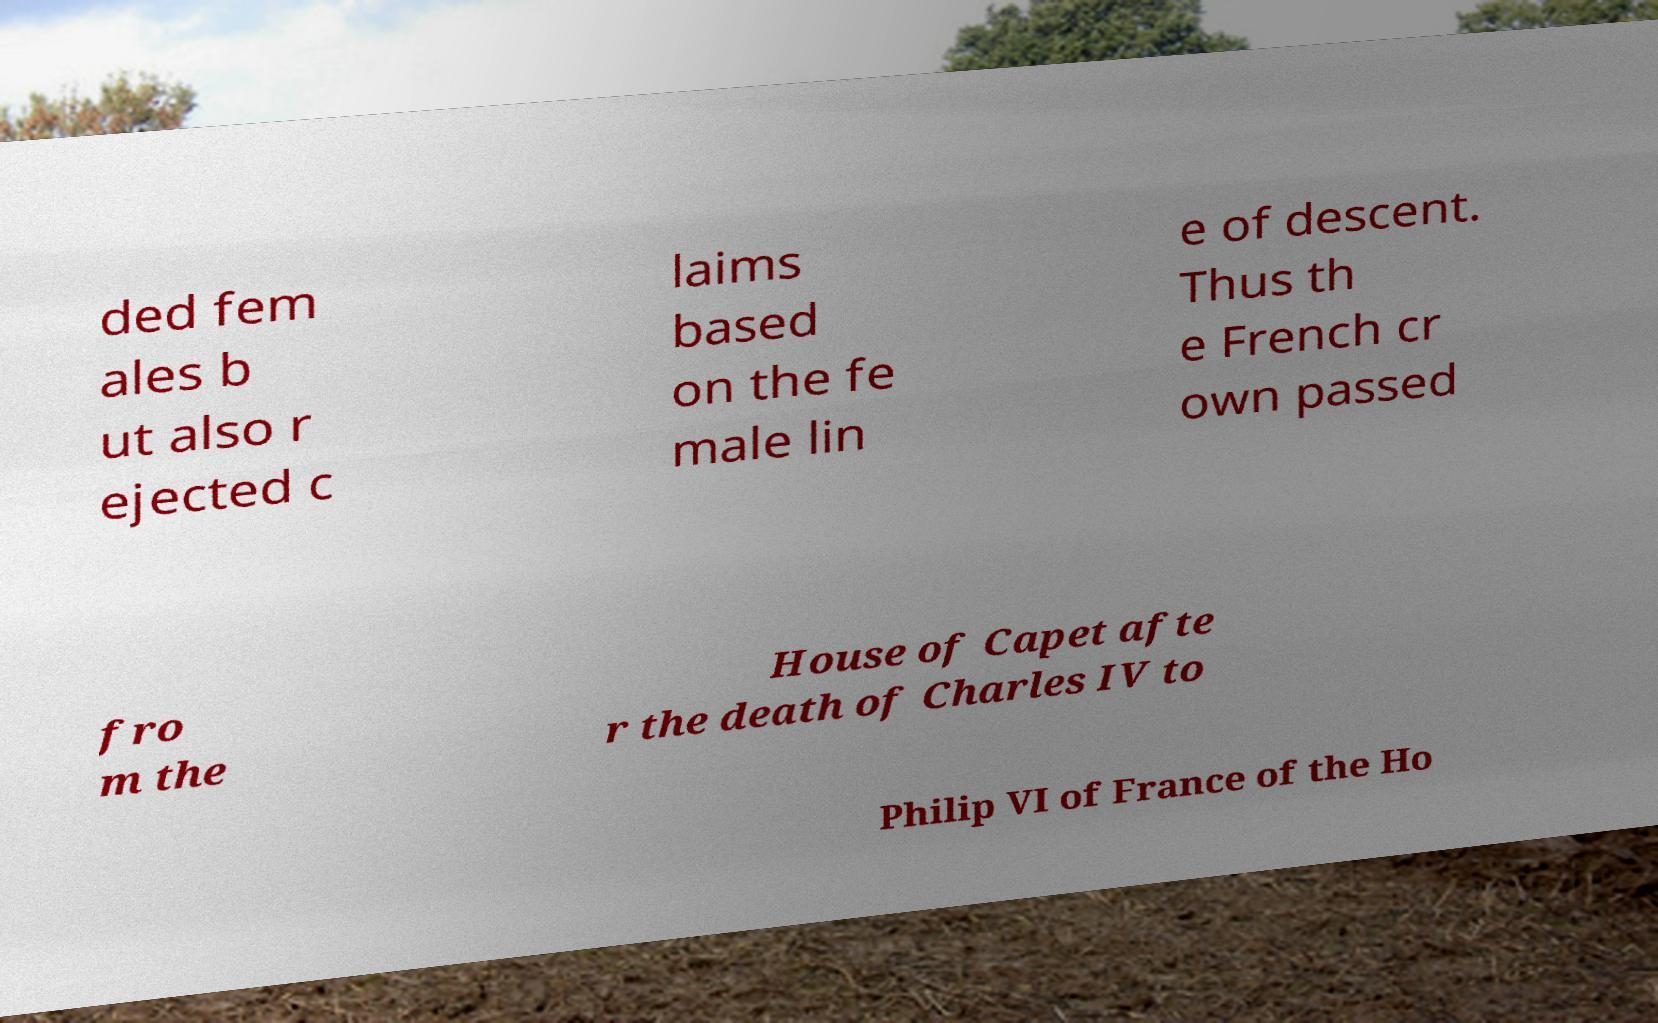What messages or text are displayed in this image? I need them in a readable, typed format. ded fem ales b ut also r ejected c laims based on the fe male lin e of descent. Thus th e French cr own passed fro m the House of Capet afte r the death of Charles IV to Philip VI of France of the Ho 